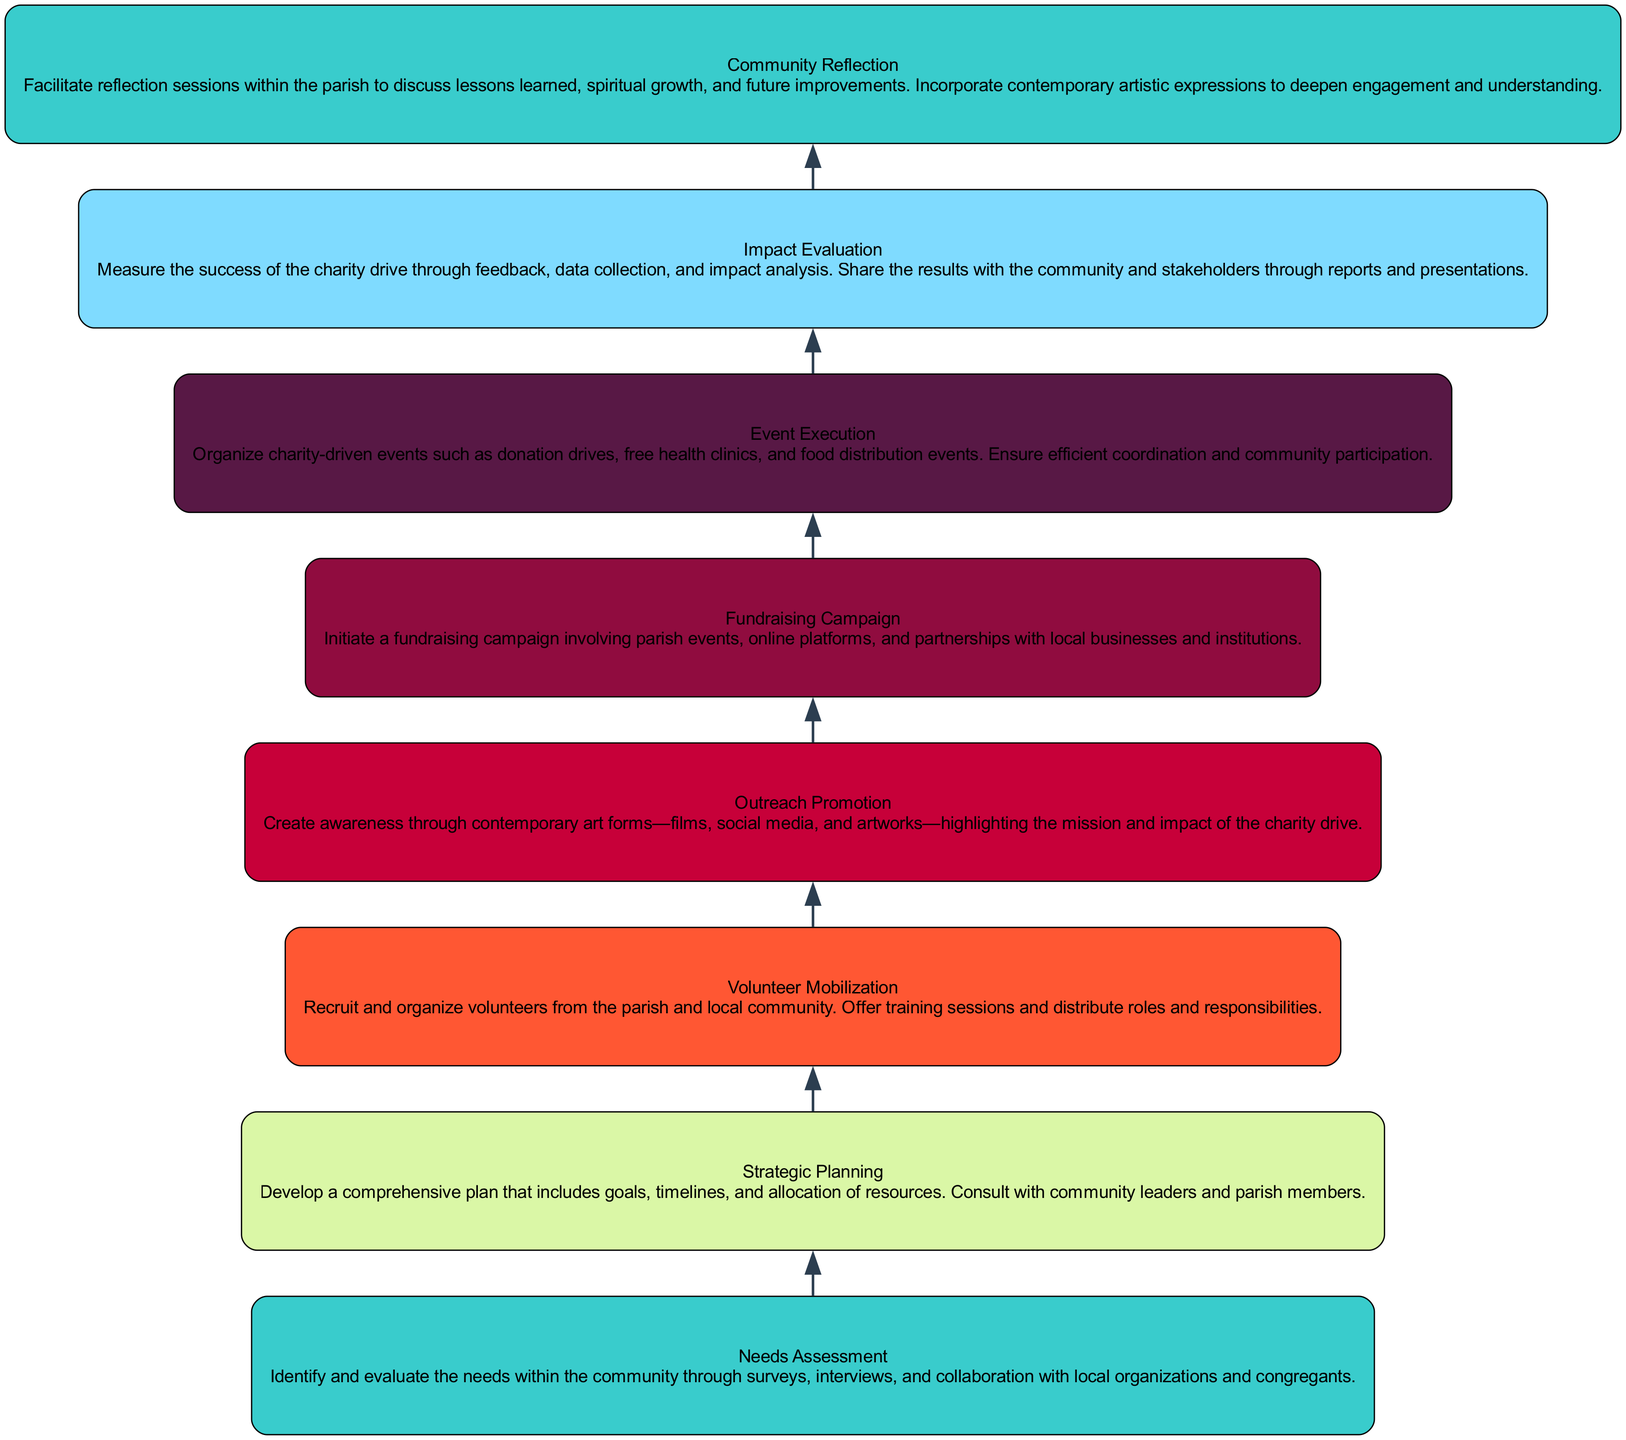What is the first stage in the Community Charity Drive? The first stage in the flow chart is labeled "Needs Assessment." This node sits at the bottom of the diagram and serves as the foundation for subsequent stages.
Answer: Needs Assessment How many nodes are there in total? By counting each distinct level represented in the diagram, including the base and levels, there are a total of 8 nodes present in the flow chart.
Answer: 8 Which stage follows Volunteer Mobilization? The stage that directly follows "Volunteer Mobilization" in the flow chart is "Outreach Promotion." This can be seen as the arrows flow upward from one stage to the next.
Answer: Outreach Promotion What is the emphasis of the Outreach Promotion stage? The emphasis of the "Outreach Promotion" stage is to create awareness through contemporary art forms, which is explicitly mentioned in the description of this node.
Answer: Contemporary art forms What is the last stage in the Community Charity Drive, and what does it focus on? The last stage is "Community Reflection," which focuses on facilitating reflection sessions within the parish to discuss lessons learned and improvements, incorporating artistic expressions.
Answer: Community Reflection How many levels are categorized above the Needs Assessment stage? There are 7 levels above the "Needs Assessment" stage, starting from "Strategic Planning" up to "Community Reflection." Each subsequent level builds on the prior one.
Answer: 7 Which two stages are linked directly before Fundraising Campaign? The two stages linked directly before "Fundraising Campaign" are "Outreach Promotion" and "Volunteer Mobilization." The arrows in the diagram show the flow from these stages leading to fundraising activities.
Answer: Outreach Promotion, Volunteer Mobilization What is the main activity described in the Event Execution stage? The main activity described in the "Event Execution" stage includes organizing charity-driven events such as donation drives and free health clinics, as noted in the description of this node.
Answer: Organizing charity-driven events 